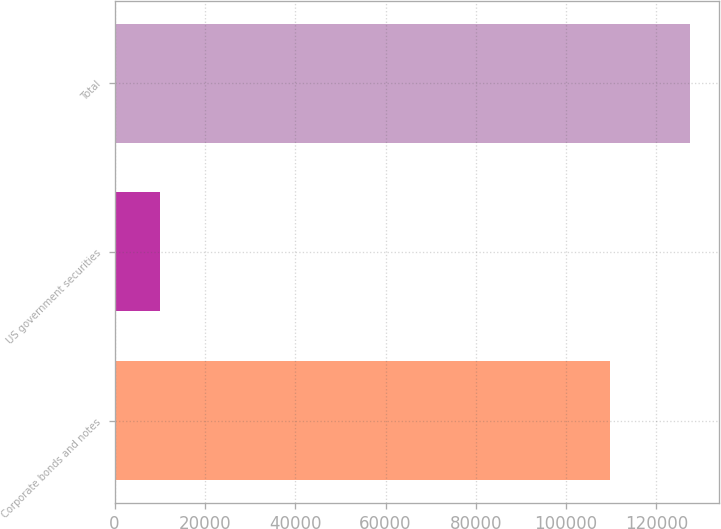Convert chart to OTSL. <chart><loc_0><loc_0><loc_500><loc_500><bar_chart><fcel>Corporate bonds and notes<fcel>US government securities<fcel>Total<nl><fcel>109613<fcel>9991<fcel>127404<nl></chart> 